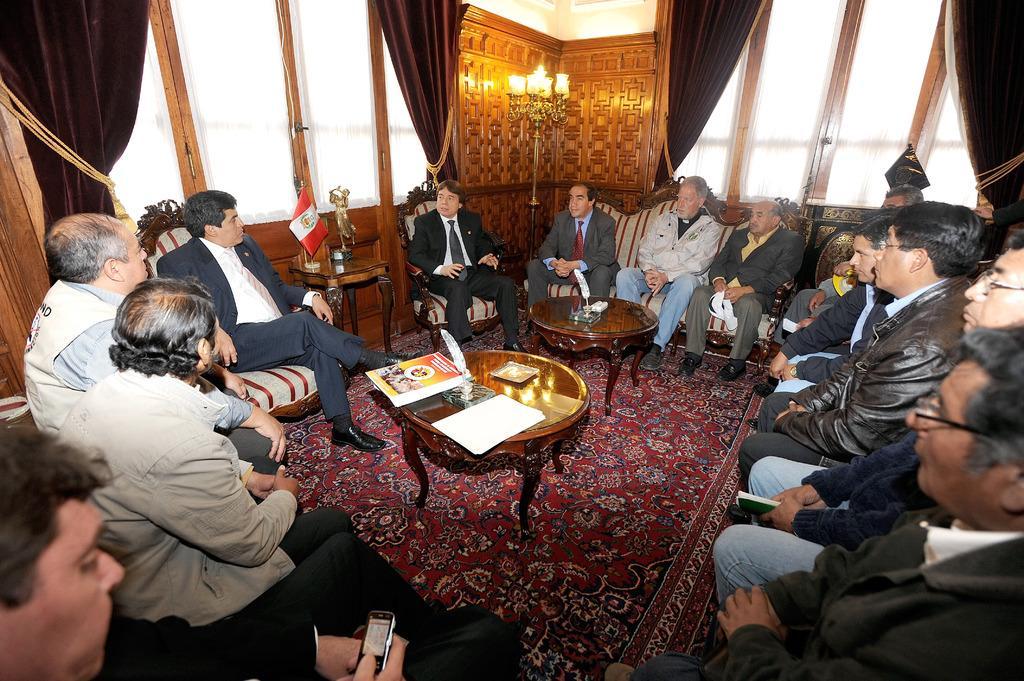Can you describe this image briefly? This picture shows a group of people seated on the chairs and we see a table and on the table we see some books and few curtains to the window and a man holding a mobile in his hand 